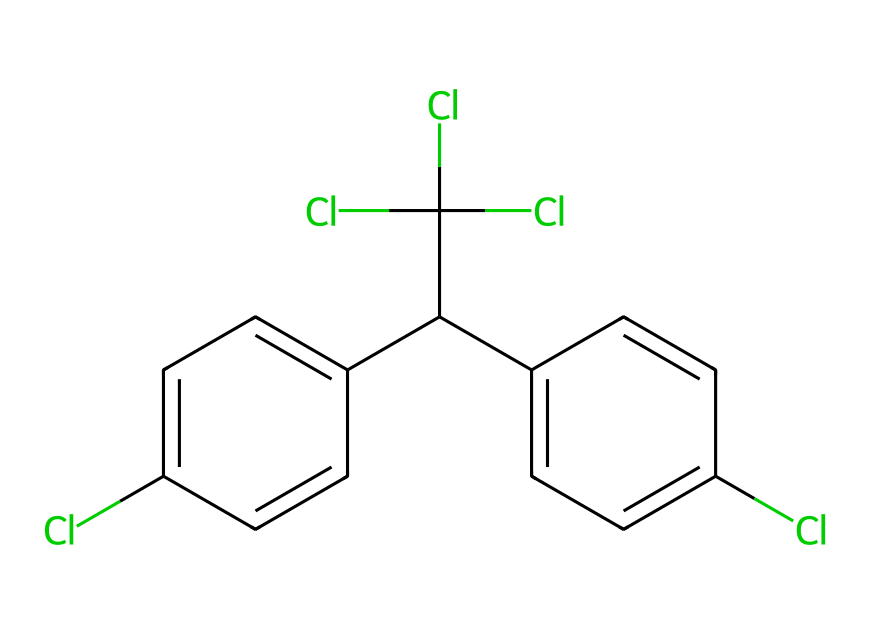What is the molecular formula of DDT based on its structure? To determine the molecular formula from the SMILES representation, we parse the chemical structure and count the individual atoms: there are 14 carbon atoms (C), 9 hydrogen atoms (H), and 4 chlorine atoms (Cl). Therefore, combining these gives us the formula C14H9Cl4.
Answer: C14H9Cl4 How many chlorine atoms are present in the DDT structure? By inspecting the SMILES representation, we can identify the presence of chlorine atoms, labeled as 'Cl'. Counting the instances of 'Cl' in the structure, there are four in total.
Answer: 4 What is the type of bonds primarily present in DDT? By analyzing the structure indicated in the SMILES notation, we can observe that the carbon atoms are predominantly bonded by single and double bonds within the aromatic rings and other groups. The presence of 'C=C' in the notation signifies double bonds among the carbon atoms.
Answer: single and double bonds Is DDT classified as a hydrocarbon? DDT, based on its structure, contains carbon and hydrogen, but also includes chlorine atoms. As hydrocarbons are defined as compounds only of hydrogen and carbon, and DDT includes chlorine, it does not fit into this category.
Answer: No What is the significance of the chlorine substitutions in the DDT structure? The chlorine substitutions on the DDT molecule increase its lipophilicity and toxicity, which are crucial for the pesticide's effectiveness. The presence of these electronegative chlorine atoms alters the chemical properties, enhancing its potency and persistence in the environment.
Answer: Increased toxicity and persistence How many rings are present in the DDT structure? Analyzing the structure, we can identify two fused aromatic rings in the SMILES representation, indicating a biphenyl structure. Each ring is characterized by alternating double bonds, consistent with aromatic compounds.
Answer: 2 What type of compound is DDT considered, based on its function and chemical structure? DDT acts as an organochlorine pesticide, characterized by the presence of multiple chlorine atoms in its structure which contribute to its activity against pests. Therefore, considering its chemical makeup and intended use, it is classified as a pesticide.
Answer: Organochlorine pesticide 